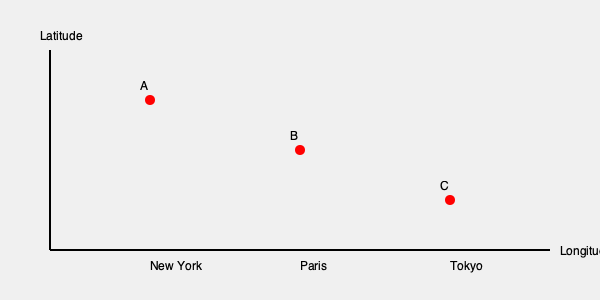On this world map representing iconic romantic movie scenes, points A, B, and C correspond to New York, Paris, and Tokyo respectively. If a character were to travel from the location of "Sleepless in Seattle" to the setting of "Amélie" and then to where "Lost in Translation" takes place, what would be the correct sequence of points visited? To answer this question, we need to follow these steps:

1. Identify the movies and their locations:
   - "Sleepless in Seattle" is set in New York and Seattle, but the iconic Empire State Building scene is in New York.
   - "Amélie" is set in Paris, France.
   - "Lost in Translation" takes place in Tokyo, Japan.

2. Match the locations to the points on the map:
   - New York (Sleepless in Seattle) = Point A
   - Paris (Amélie) = Point B
   - Tokyo (Lost in Translation) = Point C

3. Determine the sequence of travel based on the question:
   - Start at the location of "Sleepless in Seattle" (New York, Point A)
   - Travel to the setting of "Amélie" (Paris, Point B)
   - End at the location of "Lost in Translation" (Tokyo, Point C)

4. Express the sequence using the point labels:
   The correct sequence of points visited would be A → B → C.

This sequence represents a journey across three continents, showcasing the global appeal and diverse settings of romantic cinema.
Answer: A → B → C 